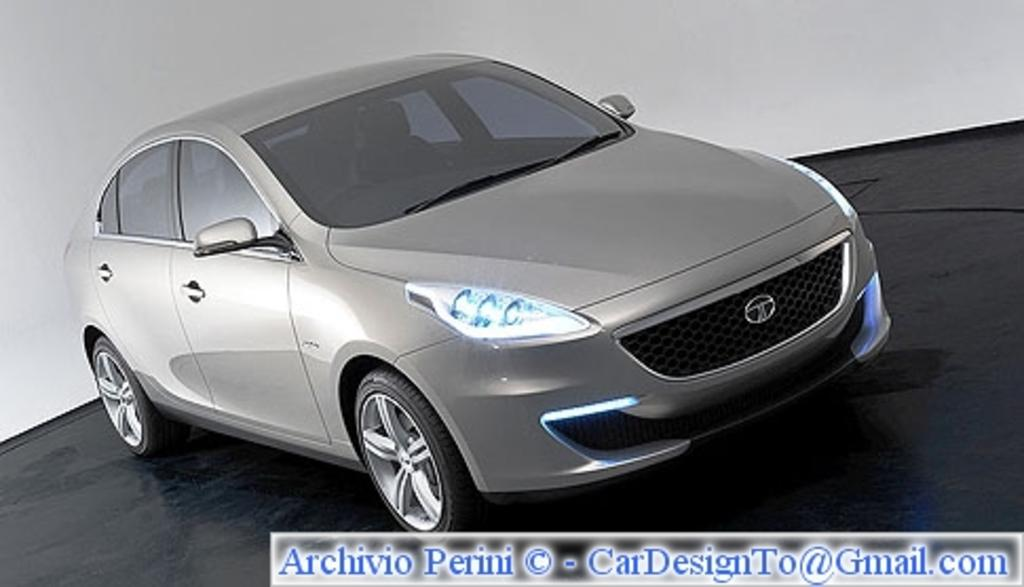What type of vehicle is in the image? There is a grey car in the image. Where is the car located? The car is parked on the floor. What color is the floor? The floor is black. What can be seen in the background of the image? There is a white wall in the background of the image. How many lizards are crawling on the apple in the image? There are no lizards or apples present in the image. 